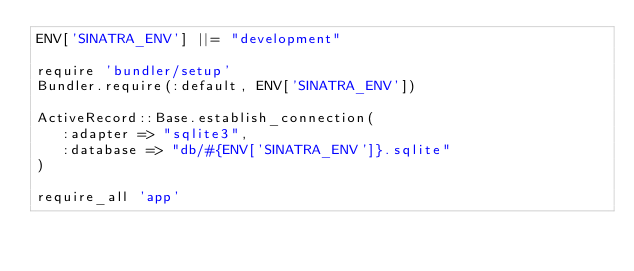<code> <loc_0><loc_0><loc_500><loc_500><_Ruby_>ENV['SINATRA_ENV'] ||= "development"

require 'bundler/setup'
Bundler.require(:default, ENV['SINATRA_ENV'])

ActiveRecord::Base.establish_connection(
   :adapter => "sqlite3",
   :database => "db/#{ENV['SINATRA_ENV']}.sqlite"
)

require_all 'app'
</code> 